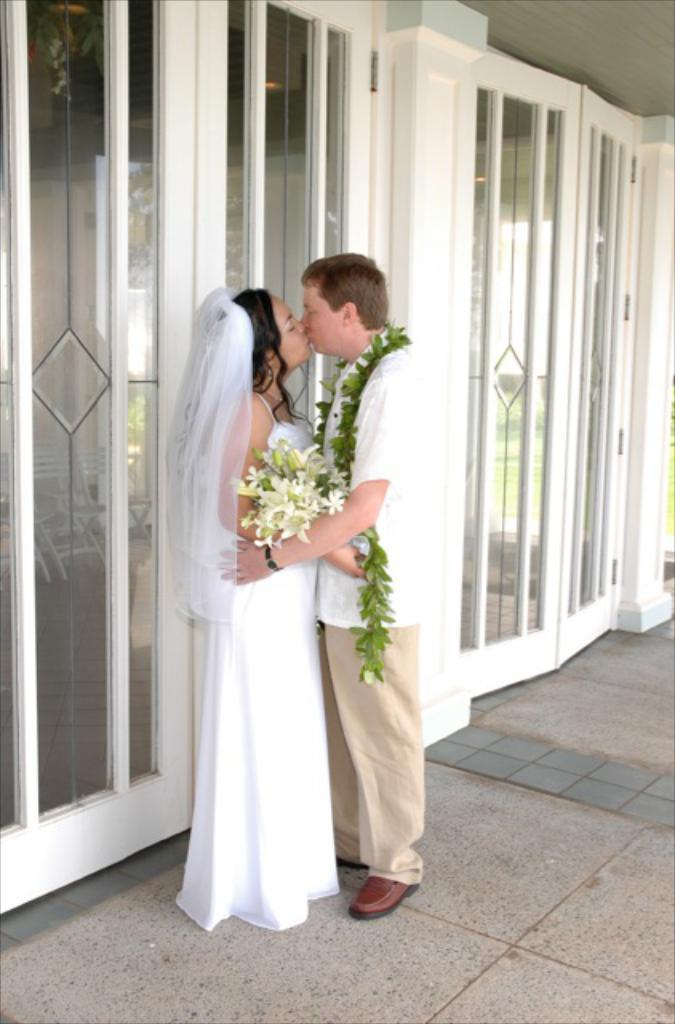What is happening between the man and the girl in the image? The man is kissing a girl in the image. What is the man wearing in the image? The man is wearing a white color shirt in the image. What is the girl wearing in the image? The girl is wearing a white color dress in the image. What type of architectural features can be seen in the image? There are glass windows and glass doors in the image. Can you describe the river flowing in the background of the image? There is no river present in the image; it features a man kissing a girl with glass windows and doors in the background. What type of crowd can be seen gathering around the scene in the image? There is no crowd present in the image; it only shows a man kissing a girl with glass windows and doors in the background. 